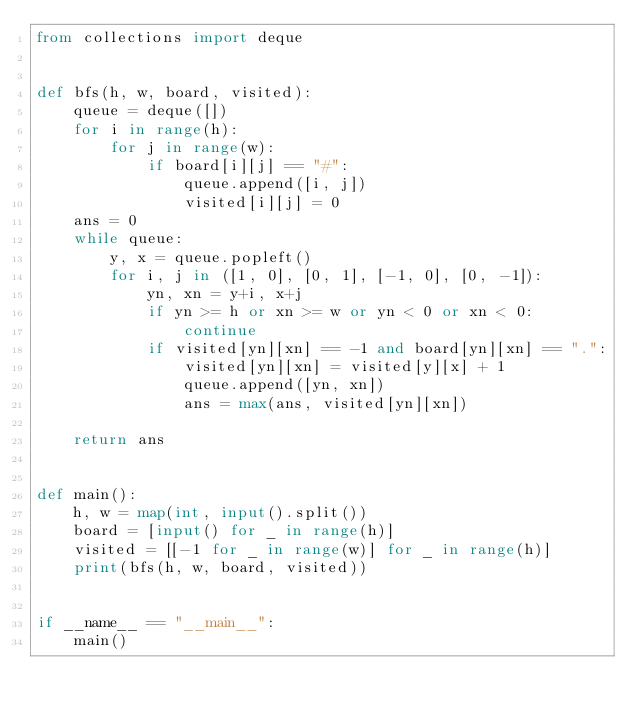<code> <loc_0><loc_0><loc_500><loc_500><_Python_>from collections import deque


def bfs(h, w, board, visited):
    queue = deque([])
    for i in range(h):
        for j in range(w):
            if board[i][j] == "#":
                queue.append([i, j])
                visited[i][j] = 0
    ans = 0
    while queue:
        y, x = queue.popleft()
        for i, j in ([1, 0], [0, 1], [-1, 0], [0, -1]):
            yn, xn = y+i, x+j
            if yn >= h or xn >= w or yn < 0 or xn < 0:
                continue
            if visited[yn][xn] == -1 and board[yn][xn] == ".":
                visited[yn][xn] = visited[y][x] + 1
                queue.append([yn, xn])
                ans = max(ans, visited[yn][xn])

    return ans


def main():
    h, w = map(int, input().split())
    board = [input() for _ in range(h)]
    visited = [[-1 for _ in range(w)] for _ in range(h)]
    print(bfs(h, w, board, visited))


if __name__ == "__main__":
    main()
</code> 